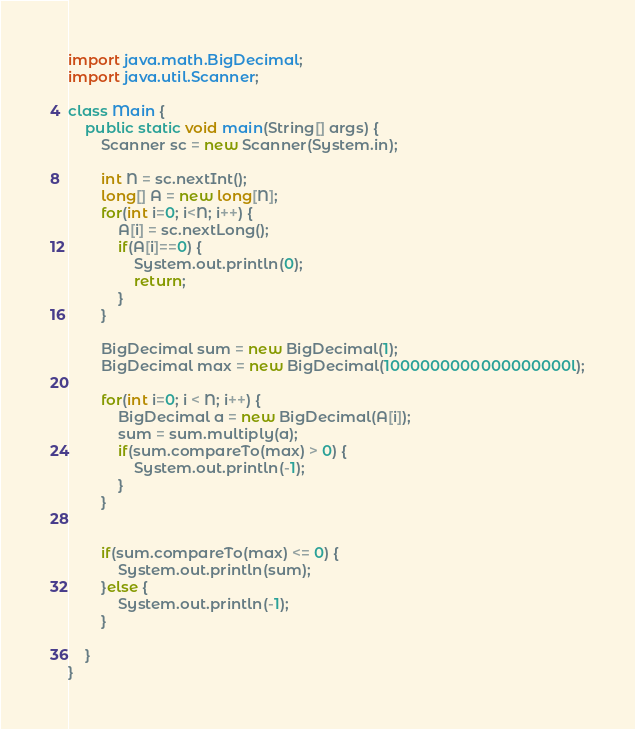<code> <loc_0><loc_0><loc_500><loc_500><_Java_>
import java.math.BigDecimal;
import java.util.Scanner;

class Main {
	public static void main(String[] args) {
		Scanner sc = new Scanner(System.in);

		int N = sc.nextInt();
		long[] A = new long[N];
		for(int i=0; i<N; i++) {
			A[i] = sc.nextLong();
			if(A[i]==0) {
				System.out.println(0);
				return;
			}
		}

		BigDecimal sum = new BigDecimal(1); 
		BigDecimal max = new BigDecimal(1000000000000000000l);

		for(int i=0; i < N; i++) {
			BigDecimal a = new BigDecimal(A[i]); 
			sum = sum.multiply(a);
			if(sum.compareTo(max) > 0) {
				System.out.println(-1);
			}
		}

		
		if(sum.compareTo(max) <= 0) {
			System.out.println(sum);
		}else {
			System.out.println(-1);
		}

	}
}

</code> 